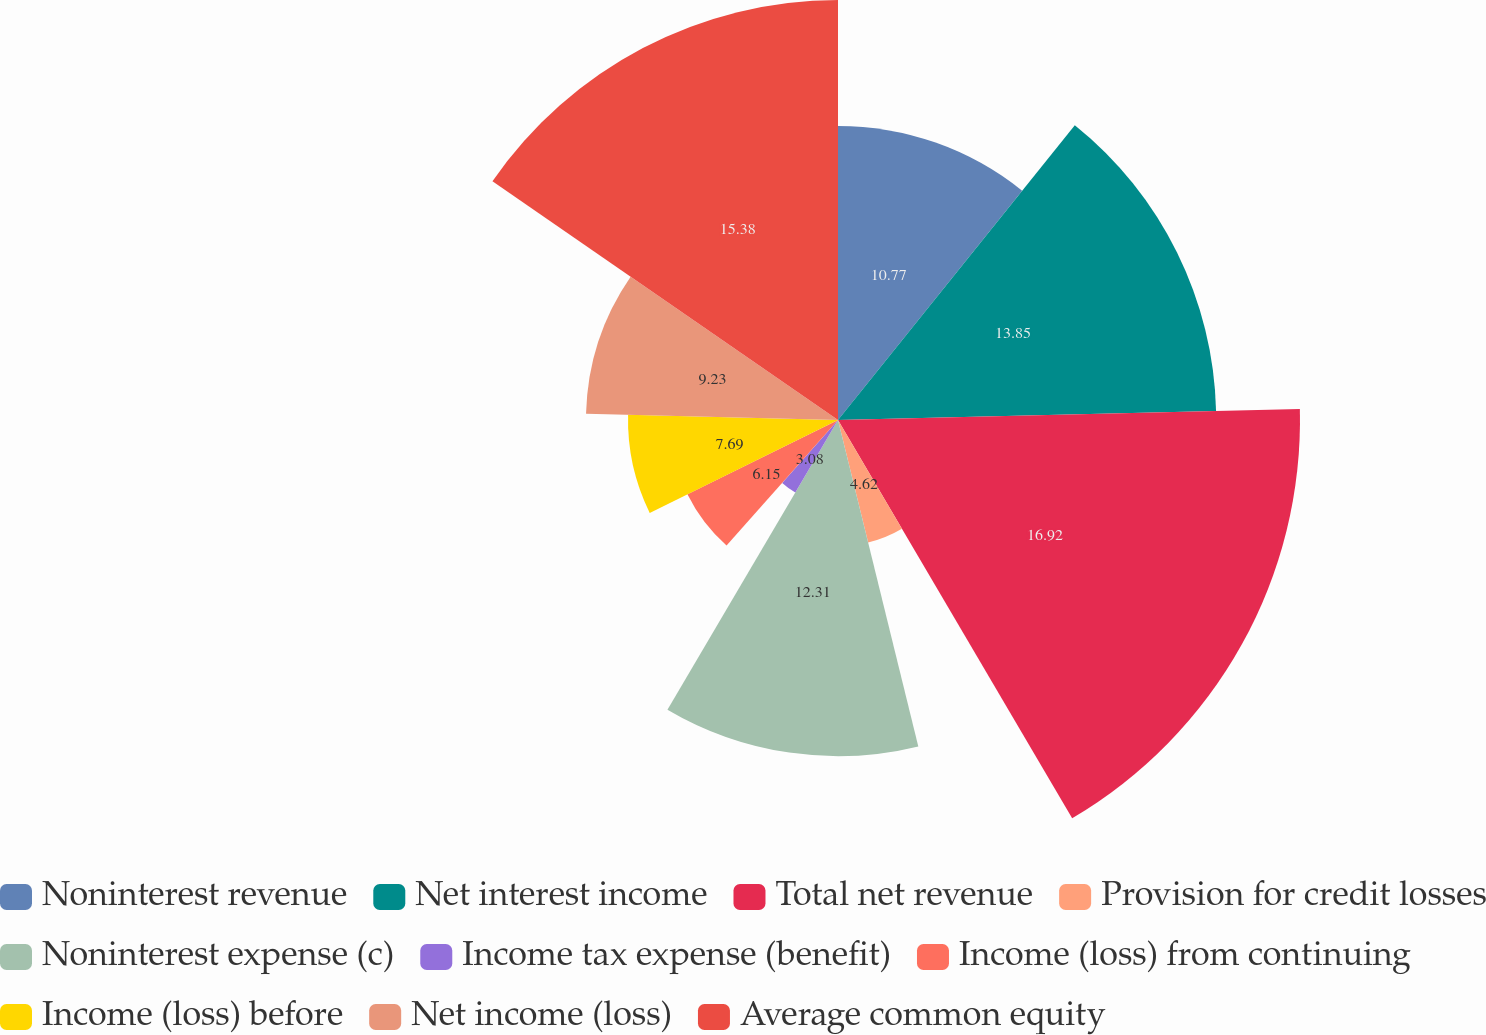Convert chart. <chart><loc_0><loc_0><loc_500><loc_500><pie_chart><fcel>Noninterest revenue<fcel>Net interest income<fcel>Total net revenue<fcel>Provision for credit losses<fcel>Noninterest expense (c)<fcel>Income tax expense (benefit)<fcel>Income (loss) from continuing<fcel>Income (loss) before<fcel>Net income (loss)<fcel>Average common equity<nl><fcel>10.77%<fcel>13.85%<fcel>16.92%<fcel>4.62%<fcel>12.31%<fcel>3.08%<fcel>6.15%<fcel>7.69%<fcel>9.23%<fcel>15.38%<nl></chart> 